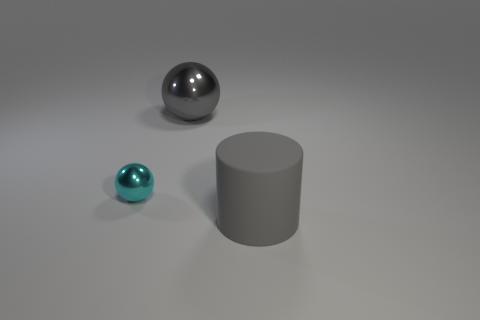Add 1 gray balls. How many objects exist? 4 Subtract all balls. How many objects are left? 1 Add 3 big gray matte objects. How many big gray matte objects exist? 4 Subtract 0 cyan cubes. How many objects are left? 3 Subtract all small cyan objects. Subtract all gray matte cylinders. How many objects are left? 1 Add 1 cylinders. How many cylinders are left? 2 